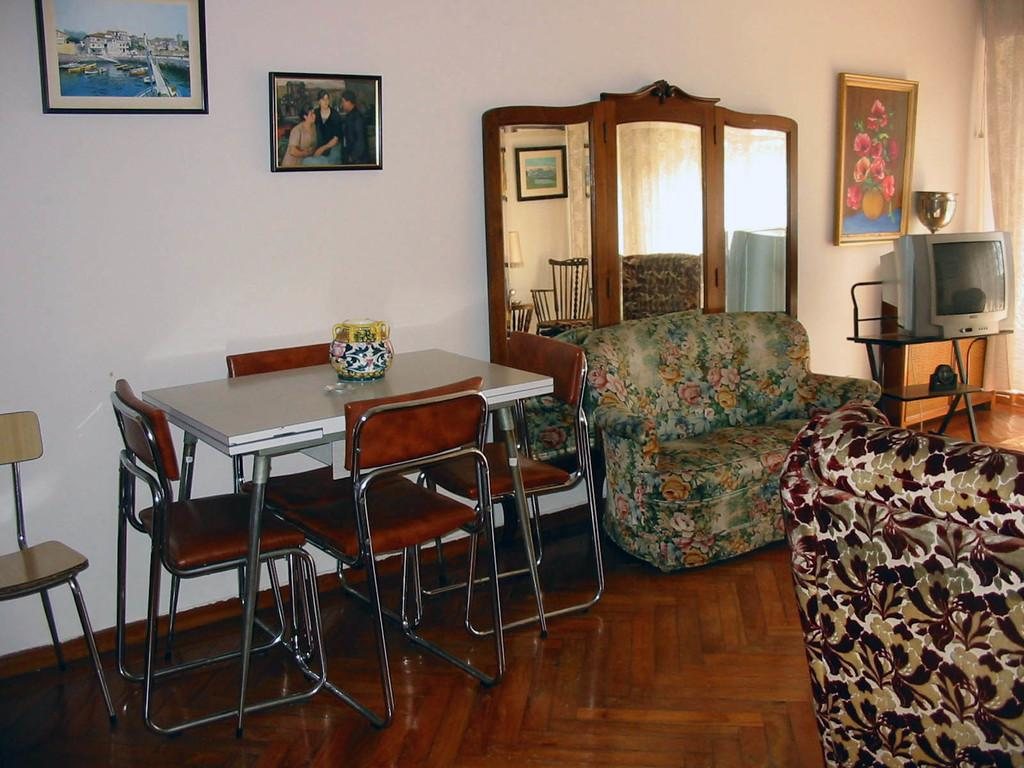What type of furniture is present in the image? There is a table and chairs in the image. What is the purpose of the table in the image? The table is likely used for dining or other activities. What electronic device can be seen in the image? There is a TV in the image. What type of seating is available on the floor? There are two couches on the floor. What type of vessel is being used to collect icicles in the image? There is no vessel or icicles present in the image. 